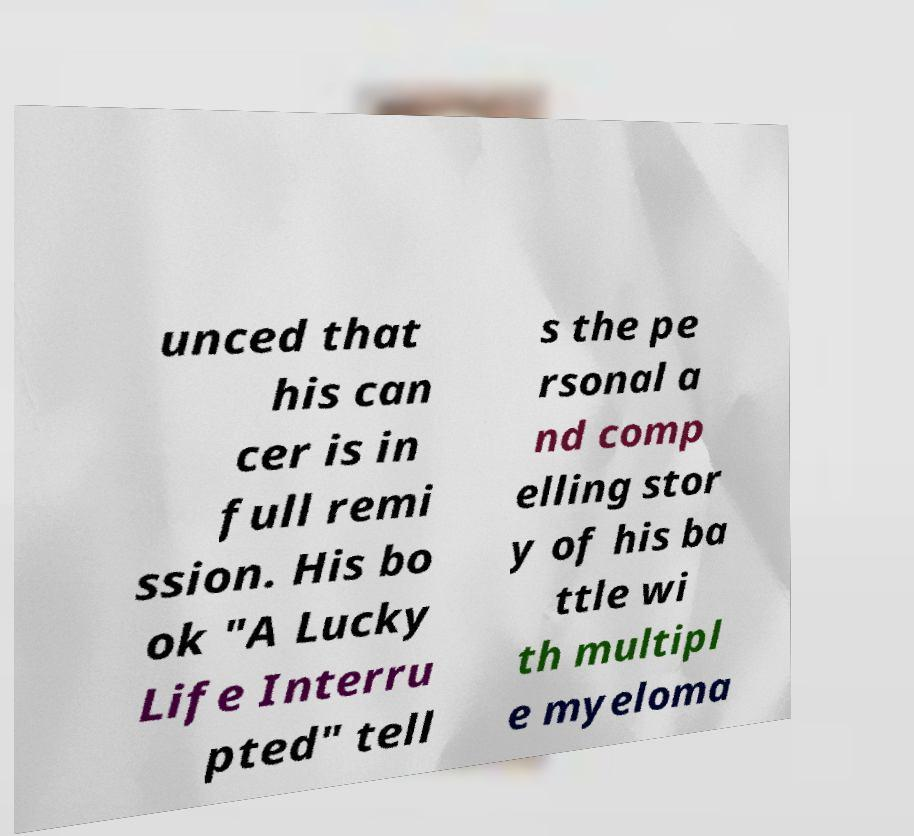Please identify and transcribe the text found in this image. unced that his can cer is in full remi ssion. His bo ok "A Lucky Life Interru pted" tell s the pe rsonal a nd comp elling stor y of his ba ttle wi th multipl e myeloma 